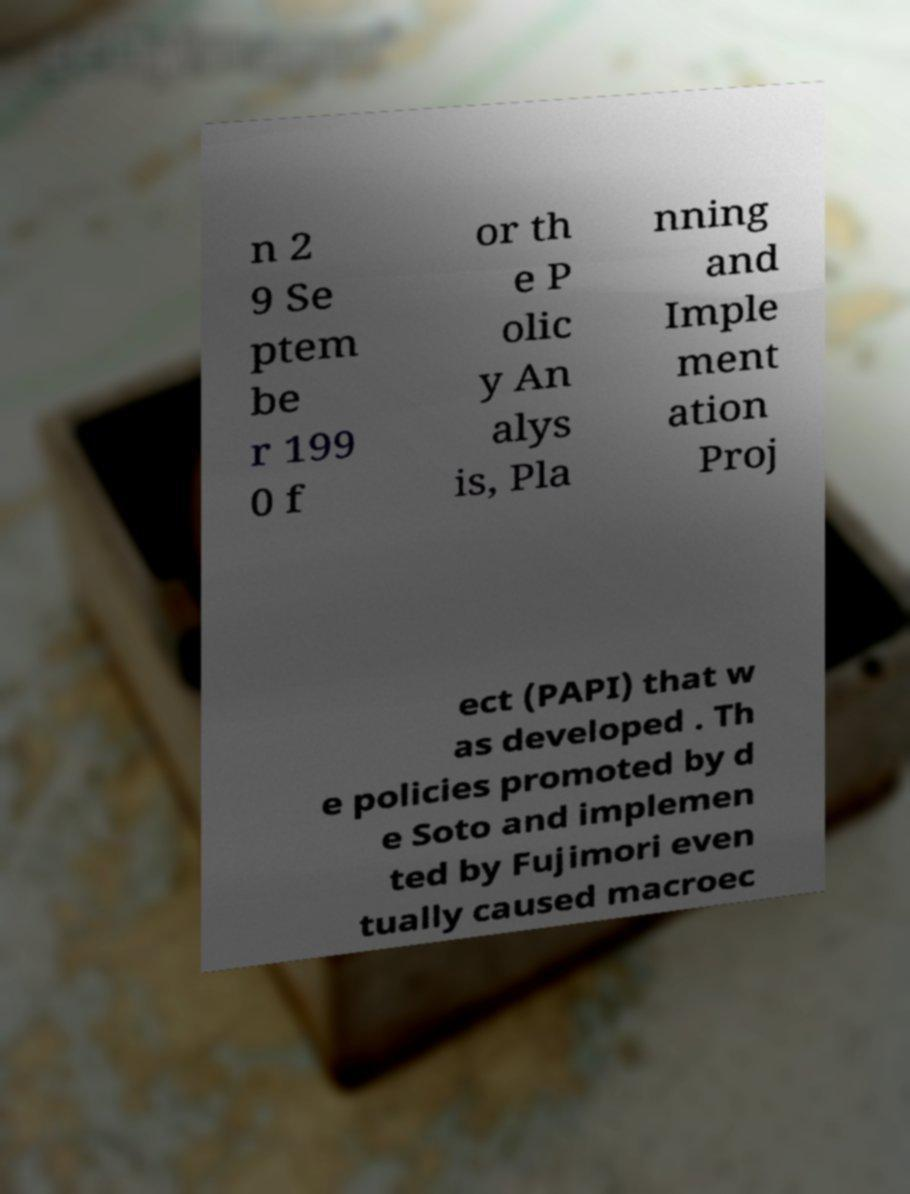Could you extract and type out the text from this image? n 2 9 Se ptem be r 199 0 f or th e P olic y An alys is, Pla nning and Imple ment ation Proj ect (PAPI) that w as developed . Th e policies promoted by d e Soto and implemen ted by Fujimori even tually caused macroec 